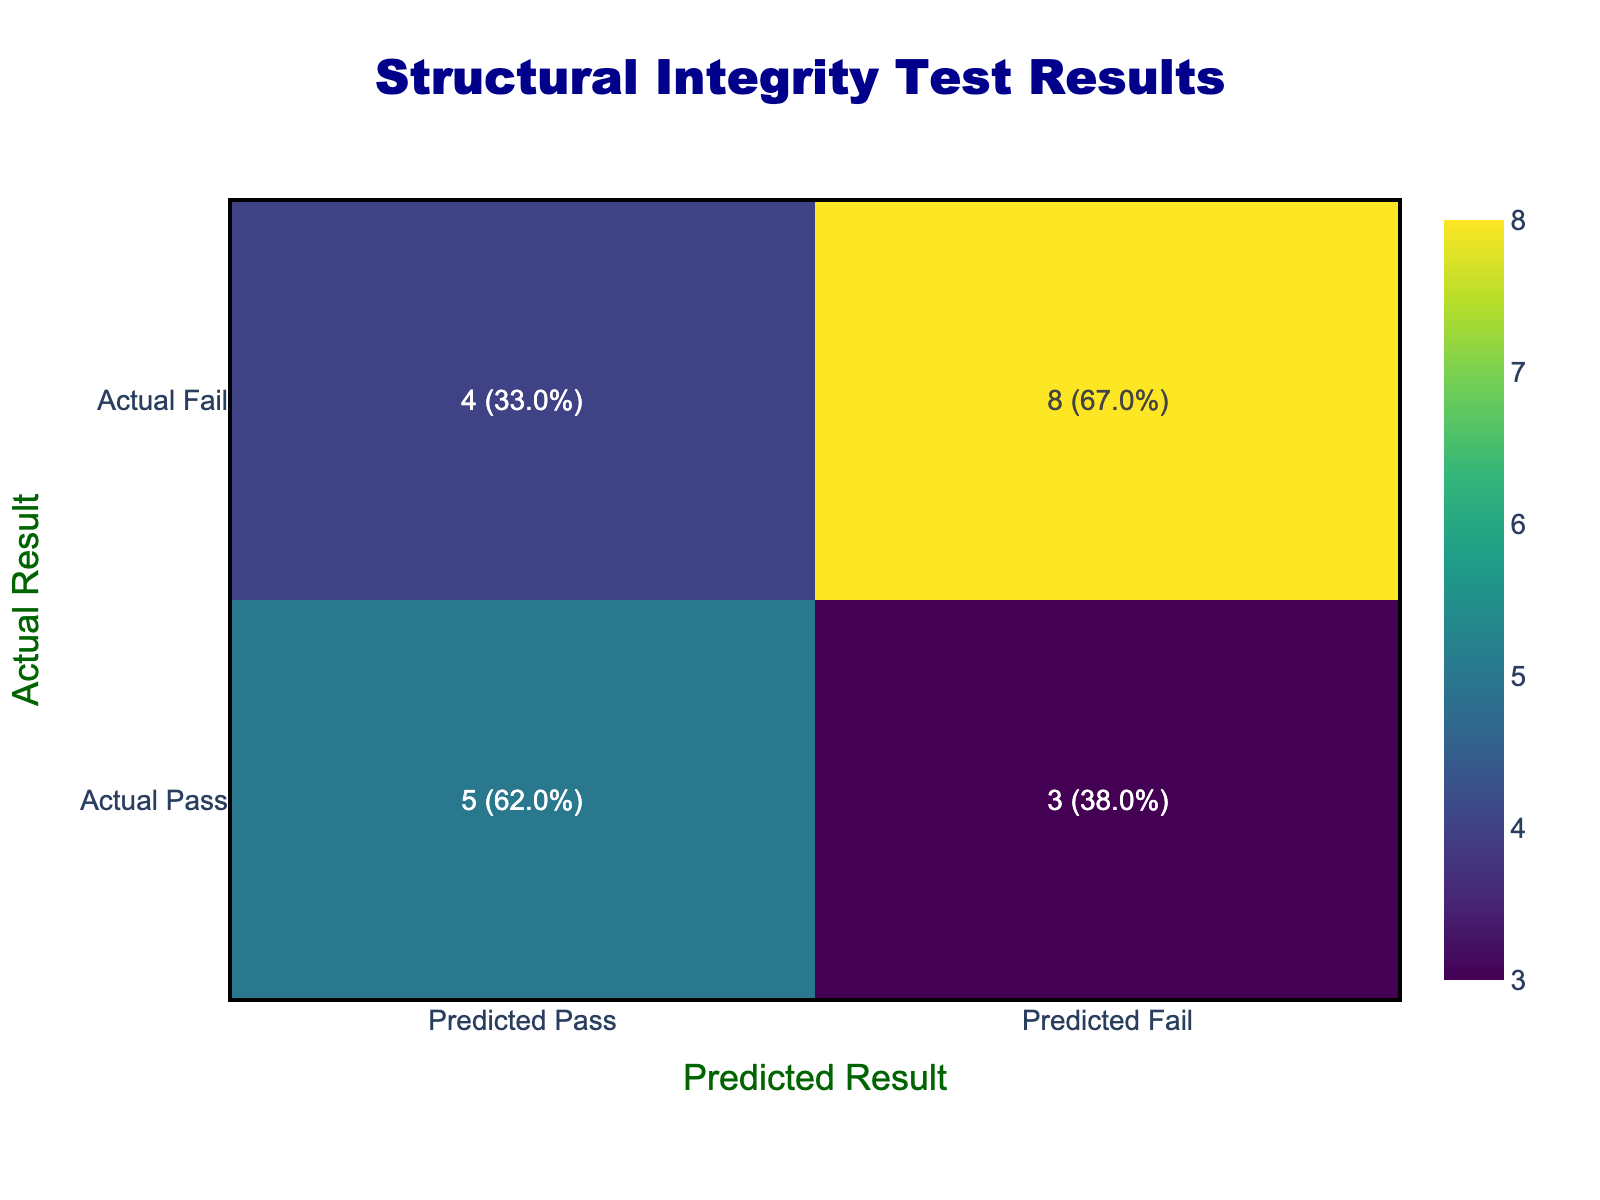What is the total number of materials that passed the test? To find the total number of materials that passed the test, we look at the row for "Actual Pass" in the confusion matrix. The count for "Predicted Pass" is 6, which includes Reinforced Concrete, Steel Beams, Masonry, Aluminum, Brick, and Fiber-Reinforced Polymer.
Answer: 6 How many materials failed the test when predicted to pass? In the confusion matrix, the row "Actual Fail" under "Predicted Pass" has a count of 3, which includes Wood, Composite Material, and PVC.
Answer: 3 What percentage of the materials that were correctly predicted as pass is represented in the table? To calculate the percentage of correctly predicted "Pass," we look at the count (6 for Predicted Pass in Actual Pass) and the total number of materials tested (12). Thus, the percentage is (6/12) * 100 = 50%.
Answer: 50% Is there a material that passed the test but was predicted to fail? By examining the table, we see under "Actual Pass" and "Predicted Fail," there are no recorded instances. Therefore, the answer is no.
Answer: No Which material had the highest discrepancy between actual and predicted results? The material with the highest discrepancy is Composite Material, which was predicted to fail (Predicted Fail) while the actual result was pass (Actual Pass). This discrepancy indicates a misclassification.
Answer: Composite Material What is the total number of false predictions in the table? To find the total number of false predictions, we add the counts from the rows for "Actual Pass" under "Predicted Fail" and "Actual Fail" under "Predicted Pass." There are 3 (Wood, Composite Material, PVC) + 3 (Glass, Steel Beams, Reinforced Concrete) totaling 6 false predictions.
Answer: 6 How many materials are correctly predicted to fail? Looking at the row for "Actual Fail" under "Predicted Fail," there are 3 materials (Glass, Composite Material, PVC) that were predicted correctly.
Answer: 3 Are there any materials that passed the test and were also predicted to pass? By checking the "Actual Pass" against "Predicted Pass," there are indeed materials that match this criteria, including Reinforced Concrete, Steel Beams, Masonry, Aluminum, Brick, and Fiber-Reinforced Polymer.
Answer: Yes What is the ratio of materials that passed the test to those that failed? There are a total of 6 materials that passed and 6 that failed (given there are a total of 12 materials). The ratio is 6:6, simplifying to 1:1.
Answer: 1:1 